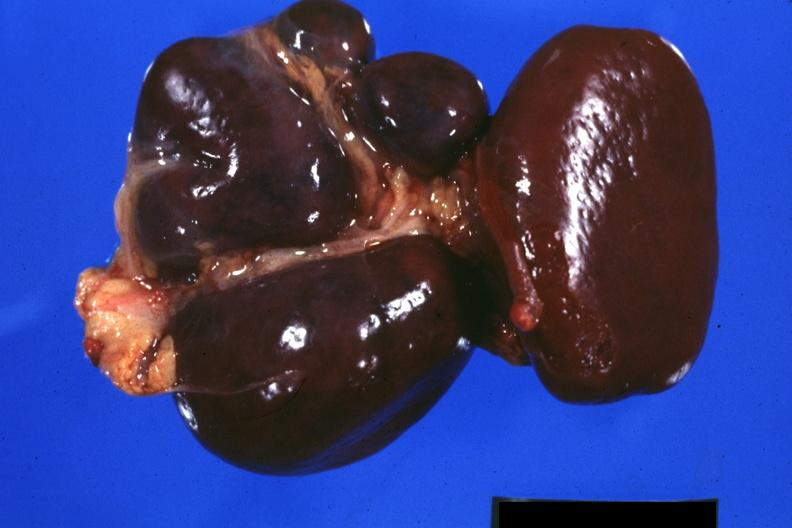s hematologic present?
Answer the question using a single word or phrase. Yes 